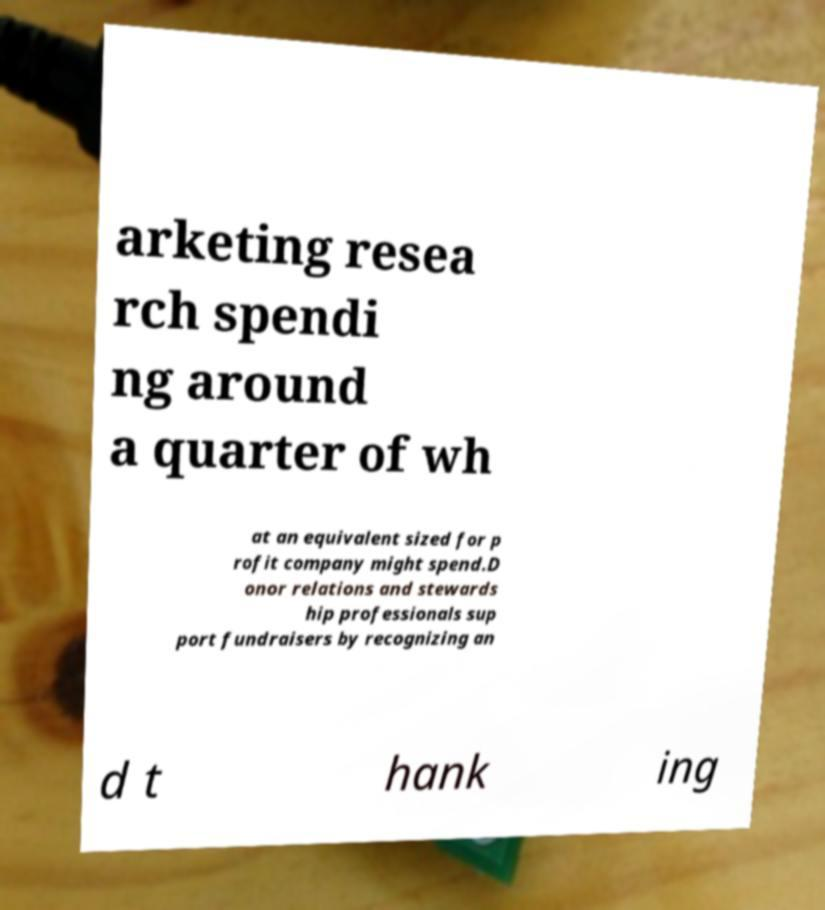Please identify and transcribe the text found in this image. arketing resea rch spendi ng around a quarter of wh at an equivalent sized for p rofit company might spend.D onor relations and stewards hip professionals sup port fundraisers by recognizing an d t hank ing 